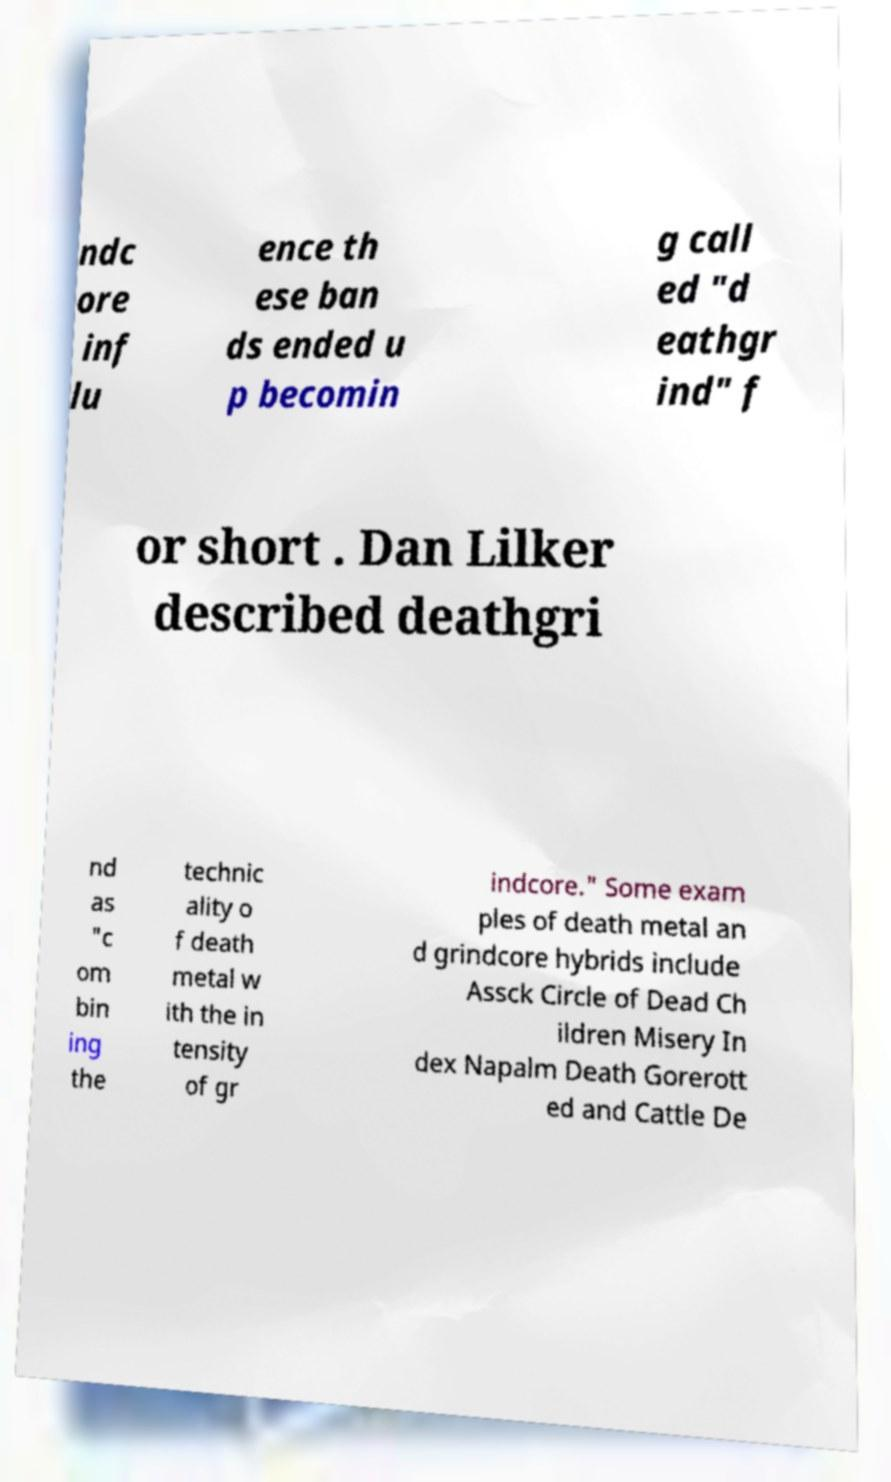Please read and relay the text visible in this image. What does it say? ndc ore inf lu ence th ese ban ds ended u p becomin g call ed "d eathgr ind" f or short . Dan Lilker described deathgri nd as "c om bin ing the technic ality o f death metal w ith the in tensity of gr indcore." Some exam ples of death metal an d grindcore hybrids include Assck Circle of Dead Ch ildren Misery In dex Napalm Death Gorerott ed and Cattle De 